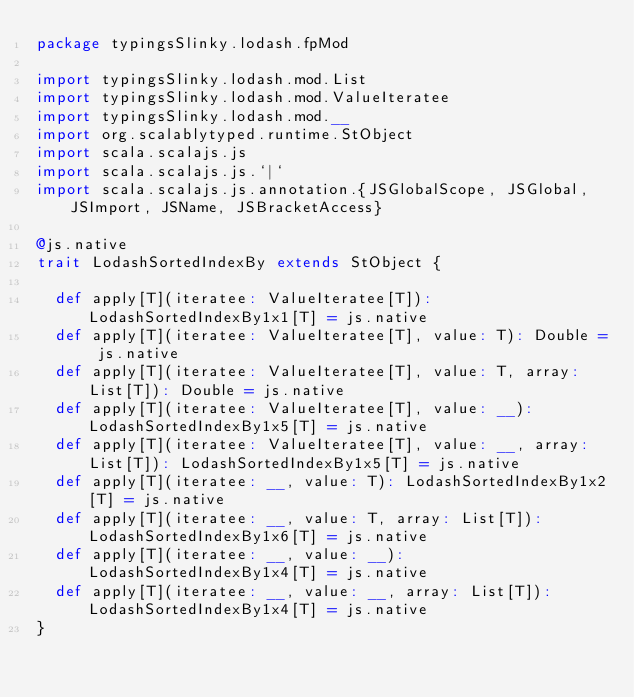<code> <loc_0><loc_0><loc_500><loc_500><_Scala_>package typingsSlinky.lodash.fpMod

import typingsSlinky.lodash.mod.List
import typingsSlinky.lodash.mod.ValueIteratee
import typingsSlinky.lodash.mod.__
import org.scalablytyped.runtime.StObject
import scala.scalajs.js
import scala.scalajs.js.`|`
import scala.scalajs.js.annotation.{JSGlobalScope, JSGlobal, JSImport, JSName, JSBracketAccess}

@js.native
trait LodashSortedIndexBy extends StObject {
  
  def apply[T](iteratee: ValueIteratee[T]): LodashSortedIndexBy1x1[T] = js.native
  def apply[T](iteratee: ValueIteratee[T], value: T): Double = js.native
  def apply[T](iteratee: ValueIteratee[T], value: T, array: List[T]): Double = js.native
  def apply[T](iteratee: ValueIteratee[T], value: __): LodashSortedIndexBy1x5[T] = js.native
  def apply[T](iteratee: ValueIteratee[T], value: __, array: List[T]): LodashSortedIndexBy1x5[T] = js.native
  def apply[T](iteratee: __, value: T): LodashSortedIndexBy1x2[T] = js.native
  def apply[T](iteratee: __, value: T, array: List[T]): LodashSortedIndexBy1x6[T] = js.native
  def apply[T](iteratee: __, value: __): LodashSortedIndexBy1x4[T] = js.native
  def apply[T](iteratee: __, value: __, array: List[T]): LodashSortedIndexBy1x4[T] = js.native
}
</code> 